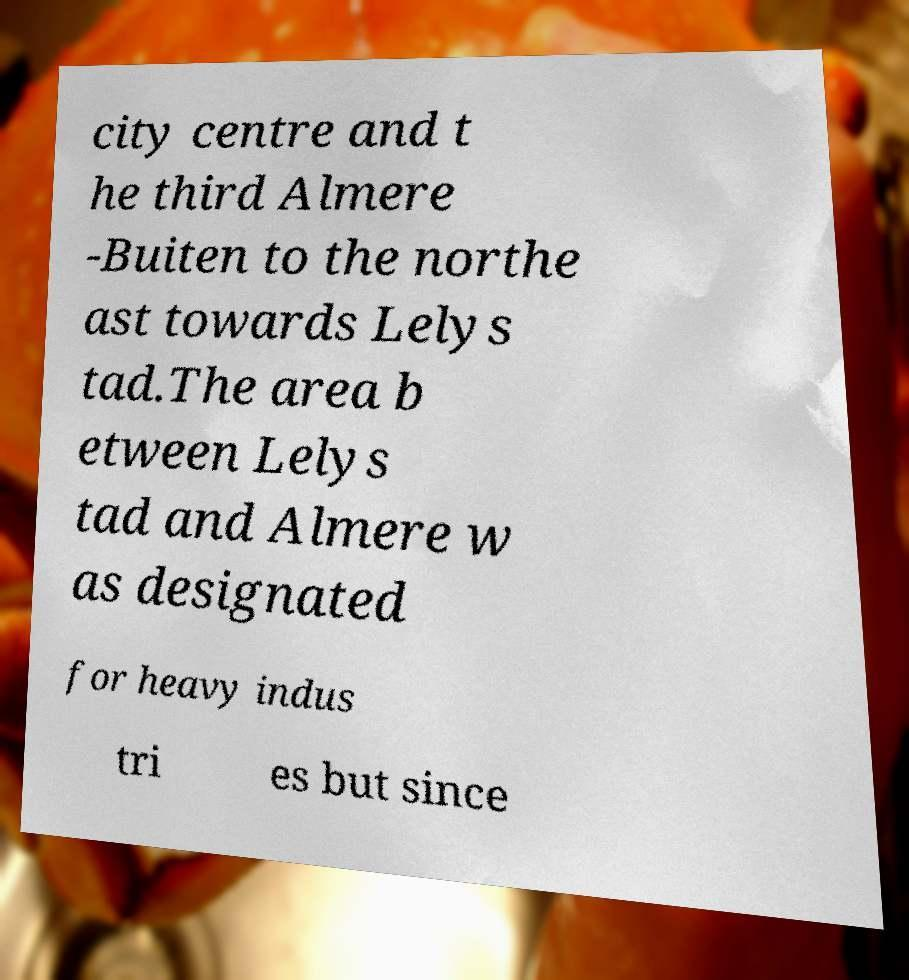For documentation purposes, I need the text within this image transcribed. Could you provide that? city centre and t he third Almere -Buiten to the northe ast towards Lelys tad.The area b etween Lelys tad and Almere w as designated for heavy indus tri es but since 